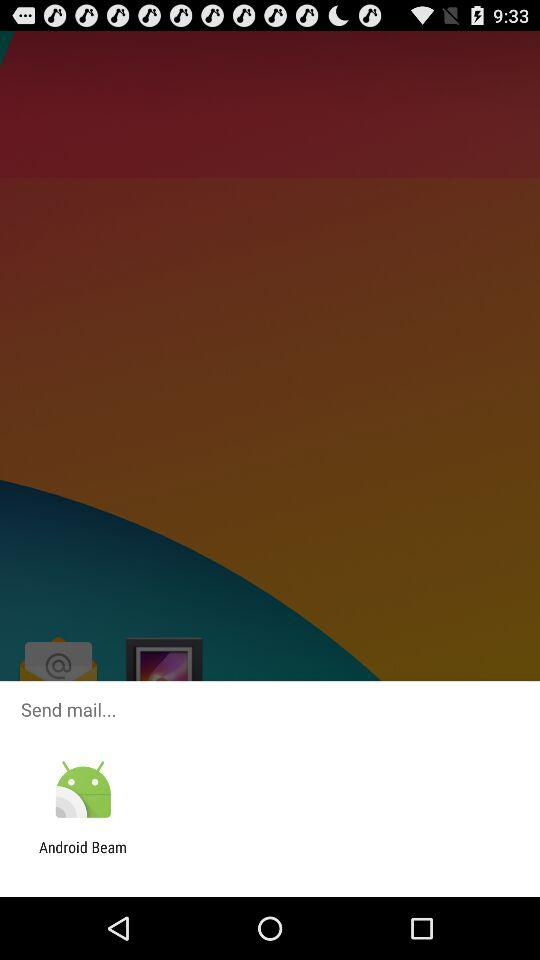Through what application can we send mail?
Answer the question using a single word or phrase. You can send email using "Android Beam." 